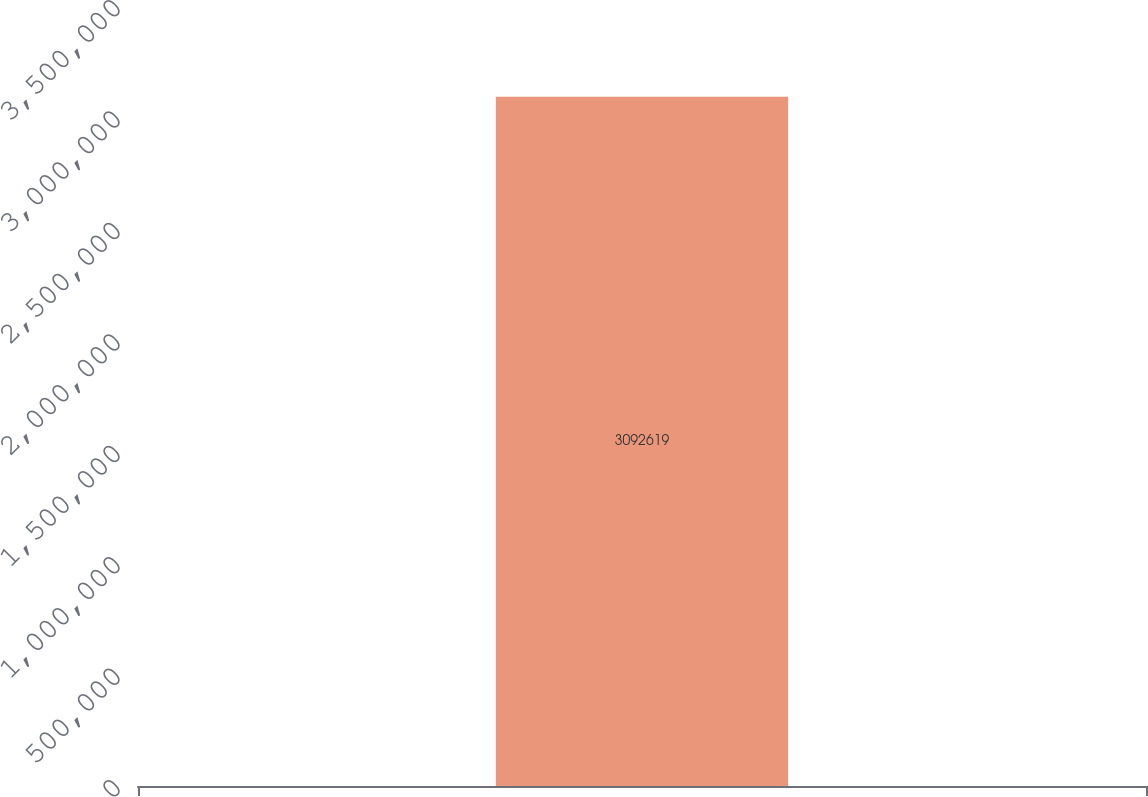Convert chart to OTSL. <chart><loc_0><loc_0><loc_500><loc_500><bar_chart><ecel><nl><fcel>3.09262e+06<nl></chart> 